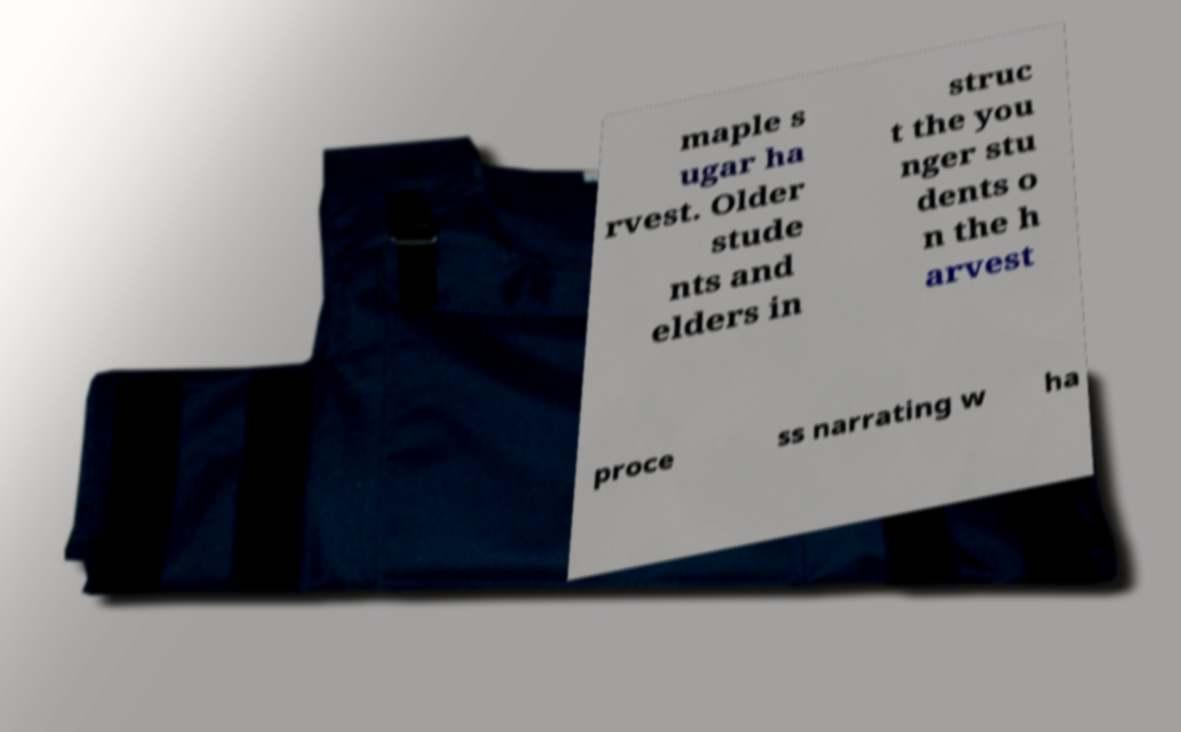Please identify and transcribe the text found in this image. maple s ugar ha rvest. Older stude nts and elders in struc t the you nger stu dents o n the h arvest proce ss narrating w ha 